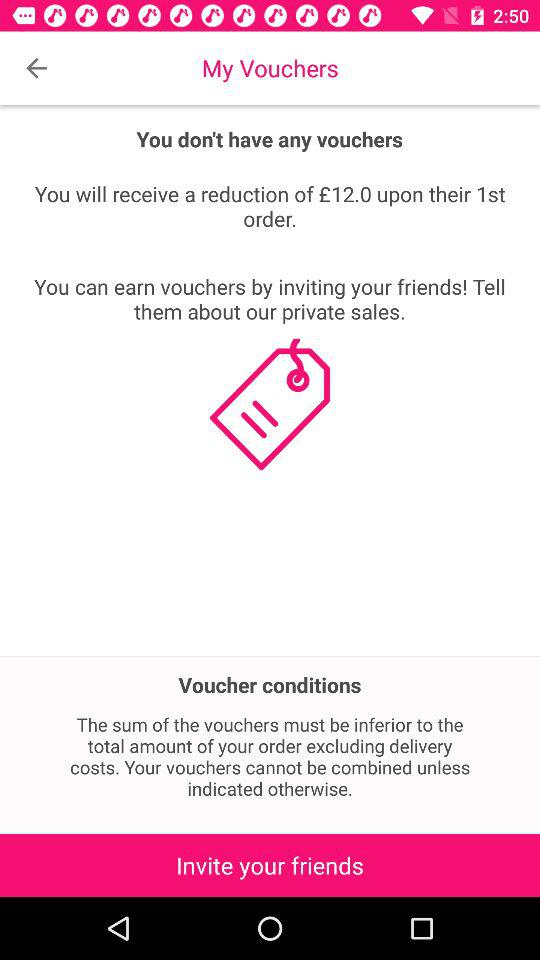What is the reduction amount? The reduction amount is £12. 